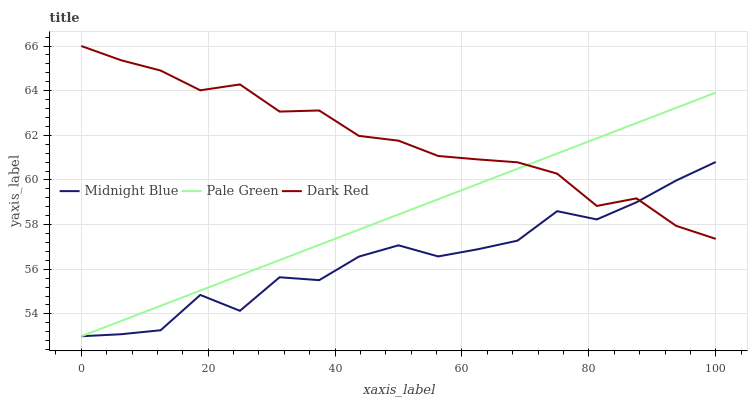Does Midnight Blue have the minimum area under the curve?
Answer yes or no. Yes. Does Dark Red have the maximum area under the curve?
Answer yes or no. Yes. Does Pale Green have the minimum area under the curve?
Answer yes or no. No. Does Pale Green have the maximum area under the curve?
Answer yes or no. No. Is Pale Green the smoothest?
Answer yes or no. Yes. Is Midnight Blue the roughest?
Answer yes or no. Yes. Is Midnight Blue the smoothest?
Answer yes or no. No. Is Pale Green the roughest?
Answer yes or no. No. Does Pale Green have the lowest value?
Answer yes or no. Yes. Does Dark Red have the highest value?
Answer yes or no. Yes. Does Pale Green have the highest value?
Answer yes or no. No. Does Midnight Blue intersect Pale Green?
Answer yes or no. Yes. Is Midnight Blue less than Pale Green?
Answer yes or no. No. Is Midnight Blue greater than Pale Green?
Answer yes or no. No. 